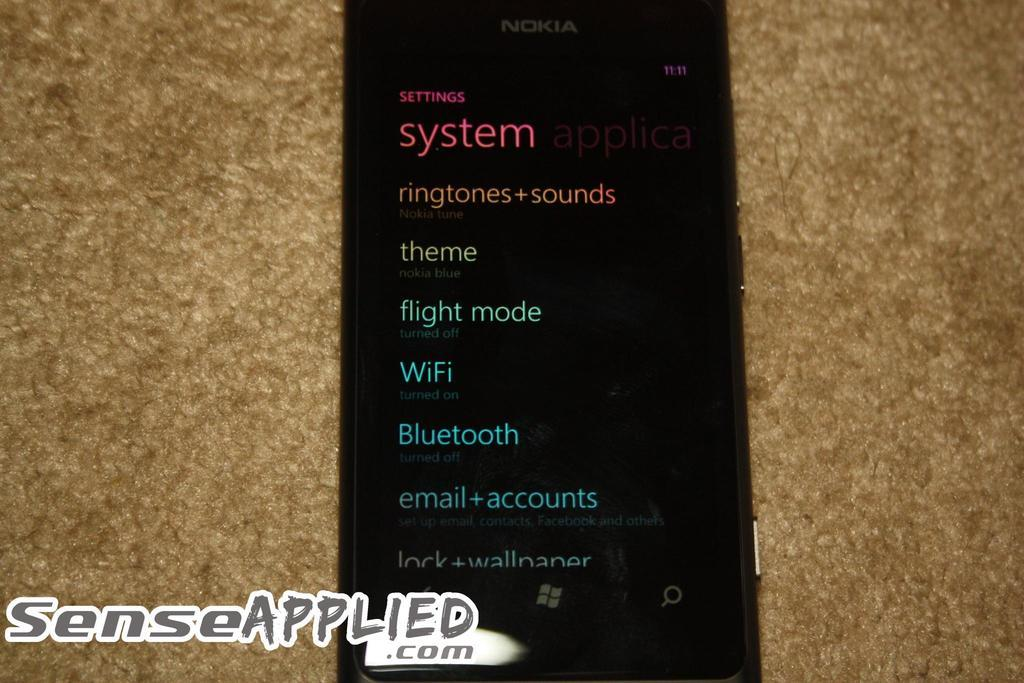<image>
Give a short and clear explanation of the subsequent image. A black Nokia cell phone displaying different system settings for apps 